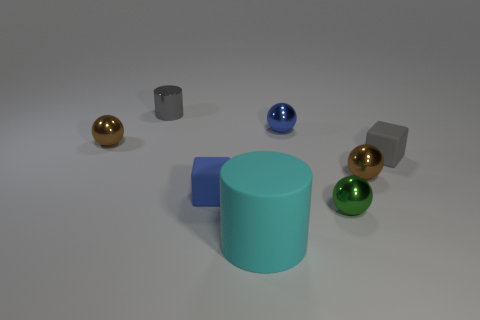Are any small gray rubber spheres visible?
Provide a short and direct response. No. How many things are either small brown metallic balls that are right of the cyan matte cylinder or blue metal things?
Give a very brief answer. 2. There is a blue object in front of the tiny gray rubber block that is behind the blue matte block; what number of small blue cubes are behind it?
Give a very brief answer. 0. Is there anything else that is the same size as the cyan cylinder?
Keep it short and to the point. No. What is the shape of the brown thing that is on the left side of the blue thing behind the brown object on the left side of the gray shiny object?
Ensure brevity in your answer.  Sphere. What number of other objects are there of the same color as the shiny cylinder?
Provide a short and direct response. 1. What is the shape of the small brown metal thing that is in front of the tiny metal ball to the left of the small gray cylinder?
Your response must be concise. Sphere. How many large matte cylinders are on the right side of the large thing?
Your answer should be compact. 0. Are there any small gray things made of the same material as the large cyan object?
Your answer should be very brief. Yes. There is a gray cube that is the same size as the green sphere; what is its material?
Offer a terse response. Rubber. 